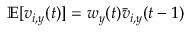<formula> <loc_0><loc_0><loc_500><loc_500>\mathbb { E } [ v _ { i , y } ( t ) ] = w _ { y } ( t ) { \bar { v } } _ { i , y } ( t - 1 )</formula> 